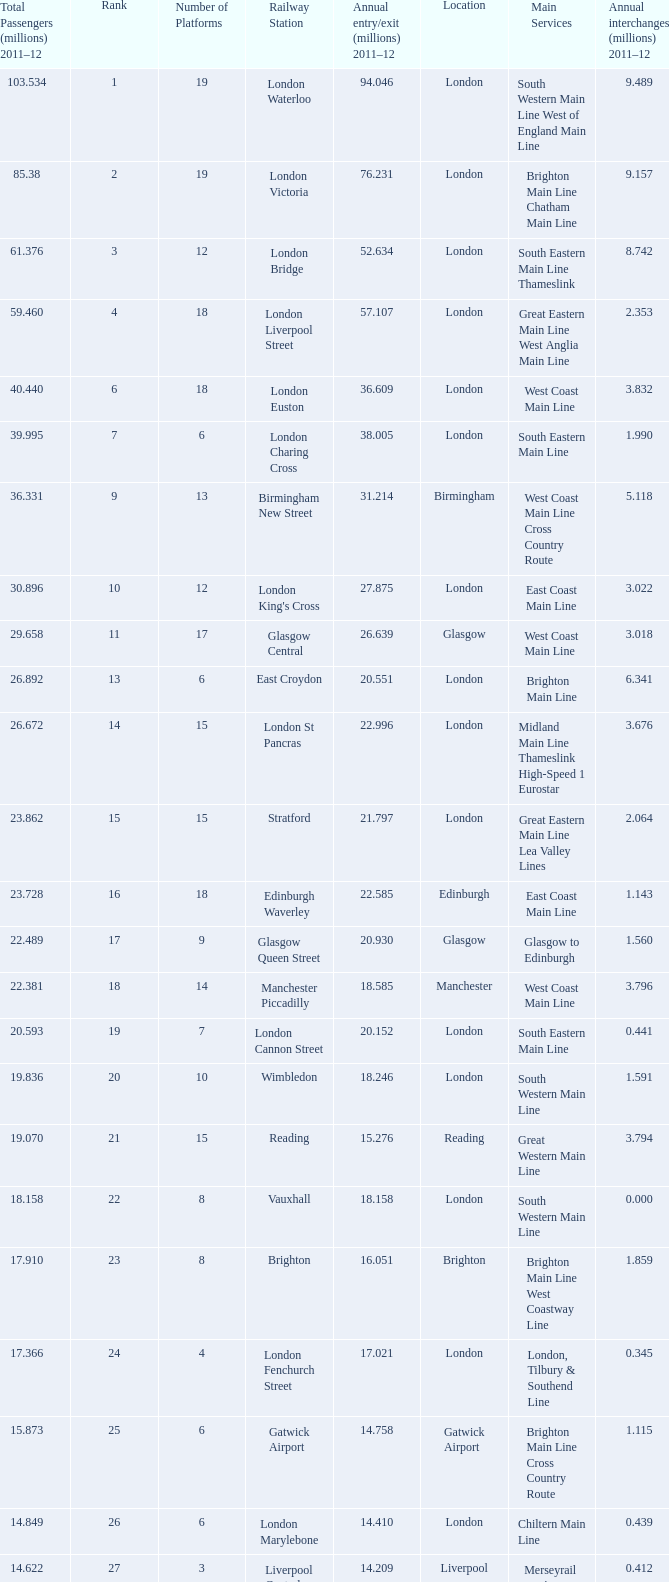Which location has 103.534 million passengers in 2011-12?  London. Would you be able to parse every entry in this table? {'header': ['Total Passengers (millions) 2011–12', 'Rank', 'Number of Platforms', 'Railway Station', 'Annual entry/exit (millions) 2011–12', 'Location', 'Main Services', 'Annual interchanges (millions) 2011–12'], 'rows': [['103.534', '1', '19', 'London Waterloo', '94.046', 'London', 'South Western Main Line West of England Main Line', '9.489'], ['85.38', '2', '19', 'London Victoria', '76.231', 'London', 'Brighton Main Line Chatham Main Line', '9.157'], ['61.376', '3', '12', 'London Bridge', '52.634', 'London', 'South Eastern Main Line Thameslink', '8.742'], ['59.460', '4', '18', 'London Liverpool Street', '57.107', 'London', 'Great Eastern Main Line West Anglia Main Line', '2.353'], ['40.440', '6', '18', 'London Euston', '36.609', 'London', 'West Coast Main Line', '3.832'], ['39.995', '7', '6', 'London Charing Cross', '38.005', 'London', 'South Eastern Main Line', '1.990'], ['36.331', '9', '13', 'Birmingham New Street', '31.214', 'Birmingham', 'West Coast Main Line Cross Country Route', '5.118'], ['30.896', '10', '12', "London King's Cross", '27.875', 'London', 'East Coast Main Line', '3.022'], ['29.658', '11', '17', 'Glasgow Central', '26.639', 'Glasgow', 'West Coast Main Line', '3.018'], ['26.892', '13', '6', 'East Croydon', '20.551', 'London', 'Brighton Main Line', '6.341'], ['26.672', '14', '15', 'London St Pancras', '22.996', 'London', 'Midland Main Line Thameslink High-Speed 1 Eurostar', '3.676'], ['23.862', '15', '15', 'Stratford', '21.797', 'London', 'Great Eastern Main Line Lea Valley Lines', '2.064'], ['23.728', '16', '18', 'Edinburgh Waverley', '22.585', 'Edinburgh', 'East Coast Main Line', '1.143'], ['22.489', '17', '9', 'Glasgow Queen Street', '20.930', 'Glasgow', 'Glasgow to Edinburgh', '1.560'], ['22.381', '18', '14', 'Manchester Piccadilly', '18.585', 'Manchester', 'West Coast Main Line', '3.796'], ['20.593', '19', '7', 'London Cannon Street', '20.152', 'London', 'South Eastern Main Line', '0.441'], ['19.836', '20', '10', 'Wimbledon', '18.246', 'London', 'South Western Main Line', '1.591'], ['19.070', '21', '15', 'Reading', '15.276', 'Reading', 'Great Western Main Line', '3.794'], ['18.158', '22', '8', 'Vauxhall', '18.158', 'London', 'South Western Main Line', '0.000'], ['17.910', '23', '8', 'Brighton', '16.051', 'Brighton', 'Brighton Main Line West Coastway Line', '1.859'], ['17.366', '24', '4', 'London Fenchurch Street', '17.021', 'London', 'London, Tilbury & Southend Line', '0.345'], ['15.873', '25', '6', 'Gatwick Airport', '14.758', 'Gatwick Airport', 'Brighton Main Line Cross Country Route', '1.115'], ['14.849', '26', '6', 'London Marylebone', '14.410', 'London', 'Chiltern Main Line', '0.439'], ['14.622', '27', '3', 'Liverpool Central', '14.209', 'Liverpool', 'Merseyrail services (Wirral and Northern lines)', '0.412'], ['14.613', '28', '10', 'Liverpool Lime Street', '13.835', 'Liverpool', 'West Coast Main Line Liverpool to Manchester Lines', '0.778'], ['13.850', '29', '4', 'London Blackfriars', '12.79', 'London', 'Thameslink', '1.059']]} 